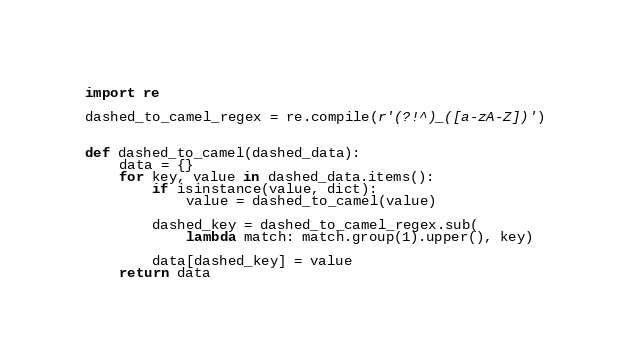Convert code to text. <code><loc_0><loc_0><loc_500><loc_500><_Python_>import re

dashed_to_camel_regex = re.compile(r'(?!^)_([a-zA-Z])')


def dashed_to_camel(dashed_data):
    data = {}
    for key, value in dashed_data.items():
        if isinstance(value, dict):
            value = dashed_to_camel(value)

        dashed_key = dashed_to_camel_regex.sub(
            lambda match: match.group(1).upper(), key)

        data[dashed_key] = value
    return data
</code> 